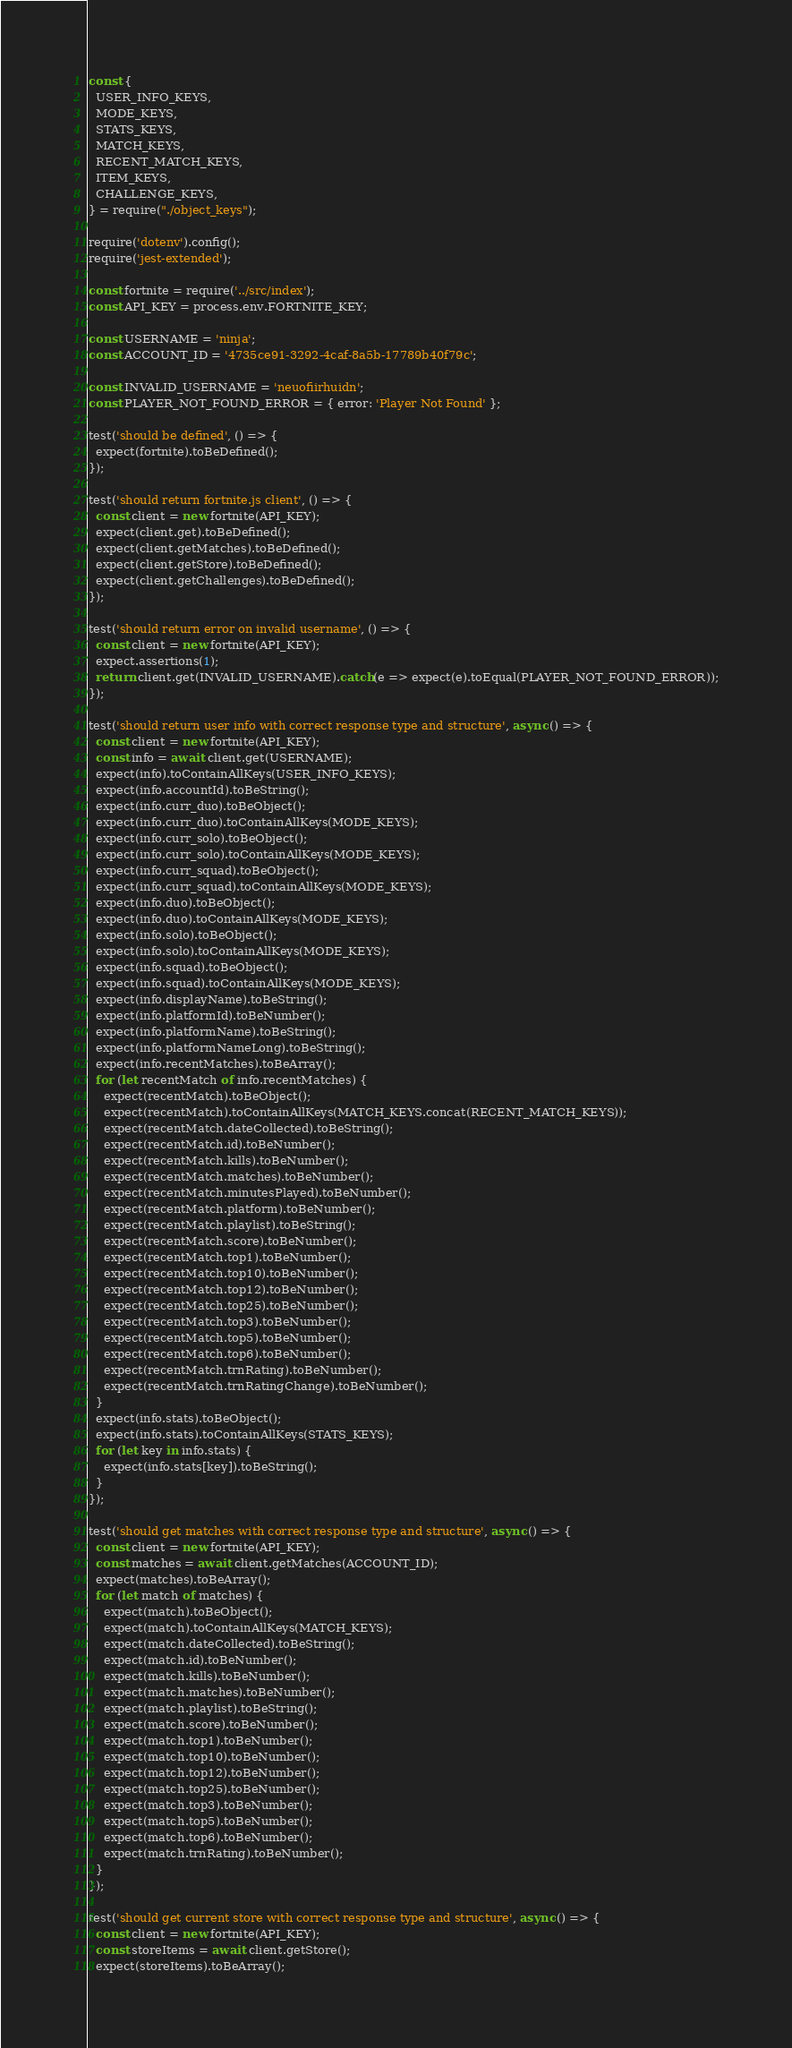Convert code to text. <code><loc_0><loc_0><loc_500><loc_500><_JavaScript_>const {
  USER_INFO_KEYS,
  MODE_KEYS,
  STATS_KEYS,
  MATCH_KEYS,
  RECENT_MATCH_KEYS,
  ITEM_KEYS,
  CHALLENGE_KEYS,
} = require("./object_keys");

require('dotenv').config();
require('jest-extended');

const fortnite = require('../src/index');
const API_KEY = process.env.FORTNITE_KEY;

const USERNAME = 'ninja';
const ACCOUNT_ID = '4735ce91-3292-4caf-8a5b-17789b40f79c';

const INVALID_USERNAME = 'neuofiirhuidn';
const PLAYER_NOT_FOUND_ERROR = { error: 'Player Not Found' };

test('should be defined', () => {
  expect(fortnite).toBeDefined();
});

test('should return fortnite.js client', () => {
  const client = new fortnite(API_KEY);
  expect(client.get).toBeDefined();
  expect(client.getMatches).toBeDefined();
  expect(client.getStore).toBeDefined();
  expect(client.getChallenges).toBeDefined();
});

test('should return error on invalid username', () => {
  const client = new fortnite(API_KEY);
  expect.assertions(1);
  return client.get(INVALID_USERNAME).catch(e => expect(e).toEqual(PLAYER_NOT_FOUND_ERROR));
});

test('should return user info with correct response type and structure', async () => {
  const client = new fortnite(API_KEY);
  const info = await client.get(USERNAME);
  expect(info).toContainAllKeys(USER_INFO_KEYS);
  expect(info.accountId).toBeString();
  expect(info.curr_duo).toBeObject();
  expect(info.curr_duo).toContainAllKeys(MODE_KEYS);
  expect(info.curr_solo).toBeObject();
  expect(info.curr_solo).toContainAllKeys(MODE_KEYS);
  expect(info.curr_squad).toBeObject();
  expect(info.curr_squad).toContainAllKeys(MODE_KEYS);
  expect(info.duo).toBeObject();
  expect(info.duo).toContainAllKeys(MODE_KEYS);
  expect(info.solo).toBeObject();
  expect(info.solo).toContainAllKeys(MODE_KEYS);
  expect(info.squad).toBeObject();
  expect(info.squad).toContainAllKeys(MODE_KEYS);
  expect(info.displayName).toBeString();
  expect(info.platformId).toBeNumber();
  expect(info.platformName).toBeString();
  expect(info.platformNameLong).toBeString();
  expect(info.recentMatches).toBeArray();
  for (let recentMatch of info.recentMatches) {
    expect(recentMatch).toBeObject();
    expect(recentMatch).toContainAllKeys(MATCH_KEYS.concat(RECENT_MATCH_KEYS));
    expect(recentMatch.dateCollected).toBeString();
    expect(recentMatch.id).toBeNumber();
    expect(recentMatch.kills).toBeNumber();
    expect(recentMatch.matches).toBeNumber();
    expect(recentMatch.minutesPlayed).toBeNumber();
    expect(recentMatch.platform).toBeNumber();
    expect(recentMatch.playlist).toBeString();
    expect(recentMatch.score).toBeNumber();
    expect(recentMatch.top1).toBeNumber();
    expect(recentMatch.top10).toBeNumber();
    expect(recentMatch.top12).toBeNumber();
    expect(recentMatch.top25).toBeNumber();
    expect(recentMatch.top3).toBeNumber();
    expect(recentMatch.top5).toBeNumber();
    expect(recentMatch.top6).toBeNumber();
    expect(recentMatch.trnRating).toBeNumber();
    expect(recentMatch.trnRatingChange).toBeNumber();
  }
  expect(info.stats).toBeObject();
  expect(info.stats).toContainAllKeys(STATS_KEYS);
  for (let key in info.stats) {
    expect(info.stats[key]).toBeString();
  }
});

test('should get matches with correct response type and structure', async () => {
  const client = new fortnite(API_KEY);
  const matches = await client.getMatches(ACCOUNT_ID);
  expect(matches).toBeArray();
  for (let match of matches) {
    expect(match).toBeObject();
    expect(match).toContainAllKeys(MATCH_KEYS);
    expect(match.dateCollected).toBeString();
    expect(match.id).toBeNumber();
    expect(match.kills).toBeNumber();
    expect(match.matches).toBeNumber();
    expect(match.playlist).toBeString();
    expect(match.score).toBeNumber();
    expect(match.top1).toBeNumber();
    expect(match.top10).toBeNumber();
    expect(match.top12).toBeNumber();
    expect(match.top25).toBeNumber();
    expect(match.top3).toBeNumber();
    expect(match.top5).toBeNumber();
    expect(match.top6).toBeNumber();
    expect(match.trnRating).toBeNumber();
  }
});

test('should get current store with correct response type and structure', async () => {
  const client = new fortnite(API_KEY);
  const storeItems = await client.getStore();
  expect(storeItems).toBeArray();</code> 